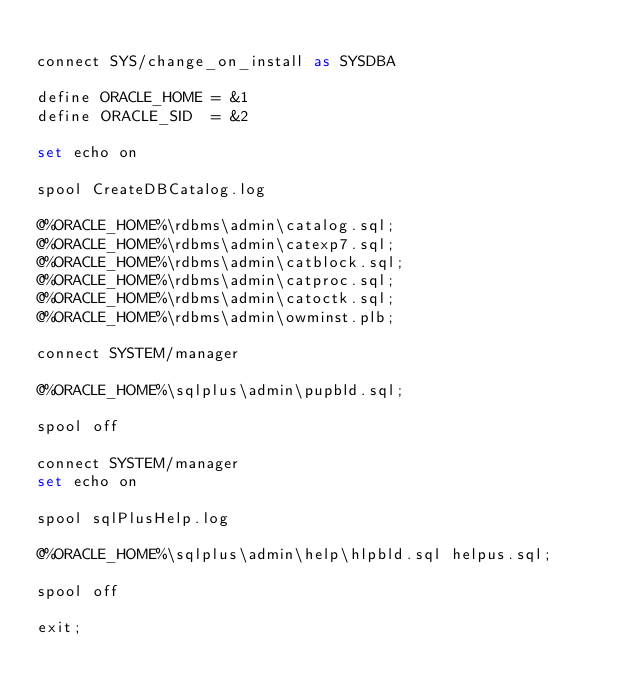Convert code to text. <code><loc_0><loc_0><loc_500><loc_500><_SQL_>
connect SYS/change_on_install as SYSDBA

define ORACLE_HOME = &1
define ORACLE_SID  = &2

set echo on

spool CreateDBCatalog.log

@%ORACLE_HOME%\rdbms\admin\catalog.sql;
@%ORACLE_HOME%\rdbms\admin\catexp7.sql;
@%ORACLE_HOME%\rdbms\admin\catblock.sql;
@%ORACLE_HOME%\rdbms\admin\catproc.sql;
@%ORACLE_HOME%\rdbms\admin\catoctk.sql;
@%ORACLE_HOME%\rdbms\admin\owminst.plb;

connect SYSTEM/manager

@%ORACLE_HOME%\sqlplus\admin\pupbld.sql;

spool off

connect SYSTEM/manager
set echo on

spool sqlPlusHelp.log

@%ORACLE_HOME%\sqlplus\admin\help\hlpbld.sql helpus.sql;

spool off

exit;
</code> 